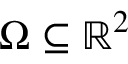Convert formula to latex. <formula><loc_0><loc_0><loc_500><loc_500>\Omega \subseteq \mathbb { R } ^ { 2 }</formula> 